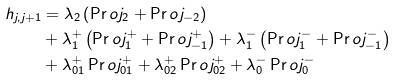<formula> <loc_0><loc_0><loc_500><loc_500>h _ { j , j + 1 } & = \lambda _ { 2 } \left ( \Pr o j _ { 2 } + \Pr o j _ { - 2 } \right ) \\ & + \lambda _ { 1 } ^ { + } \left ( \Pr o j _ { 1 } ^ { + } + \Pr o j _ { - 1 } ^ { + } \right ) + \lambda _ { 1 } ^ { - } \left ( \Pr o j _ { 1 } ^ { - } + \Pr o j _ { - 1 } ^ { - } \right ) \\ & + \lambda _ { 0 1 } ^ { + } \Pr o j _ { 0 1 } ^ { + } + \lambda _ { 0 2 } ^ { + } \Pr o j _ { 0 2 } ^ { + } + \lambda _ { 0 } ^ { - } \Pr o j _ { 0 } ^ { - }</formula> 